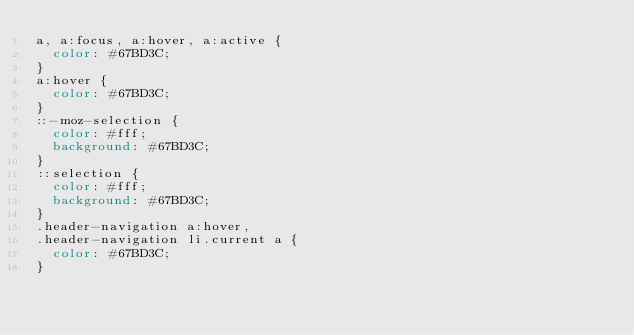Convert code to text. <code><loc_0><loc_0><loc_500><loc_500><_CSS_>a, a:focus, a:hover, a:active {
  color: #67BD3C;
}
a:hover {
  color: #67BD3C;
}
::-moz-selection {
  color: #fff;
  background: #67BD3C;
}
::selection {
  color: #fff;
  background: #67BD3C;
}
.header-navigation a:hover,
.header-navigation li.current a {
  color: #67BD3C;
}</code> 